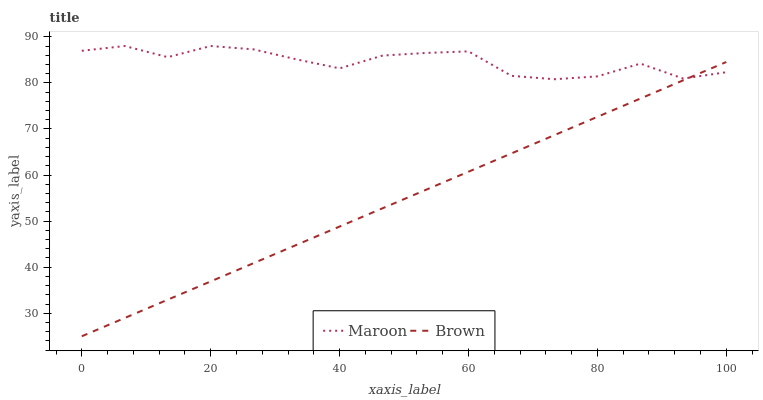Does Brown have the minimum area under the curve?
Answer yes or no. Yes. Does Maroon have the maximum area under the curve?
Answer yes or no. Yes. Does Maroon have the minimum area under the curve?
Answer yes or no. No. Is Brown the smoothest?
Answer yes or no. Yes. Is Maroon the roughest?
Answer yes or no. Yes. Is Maroon the smoothest?
Answer yes or no. No. Does Brown have the lowest value?
Answer yes or no. Yes. Does Maroon have the lowest value?
Answer yes or no. No. Does Maroon have the highest value?
Answer yes or no. Yes. Does Maroon intersect Brown?
Answer yes or no. Yes. Is Maroon less than Brown?
Answer yes or no. No. Is Maroon greater than Brown?
Answer yes or no. No. 